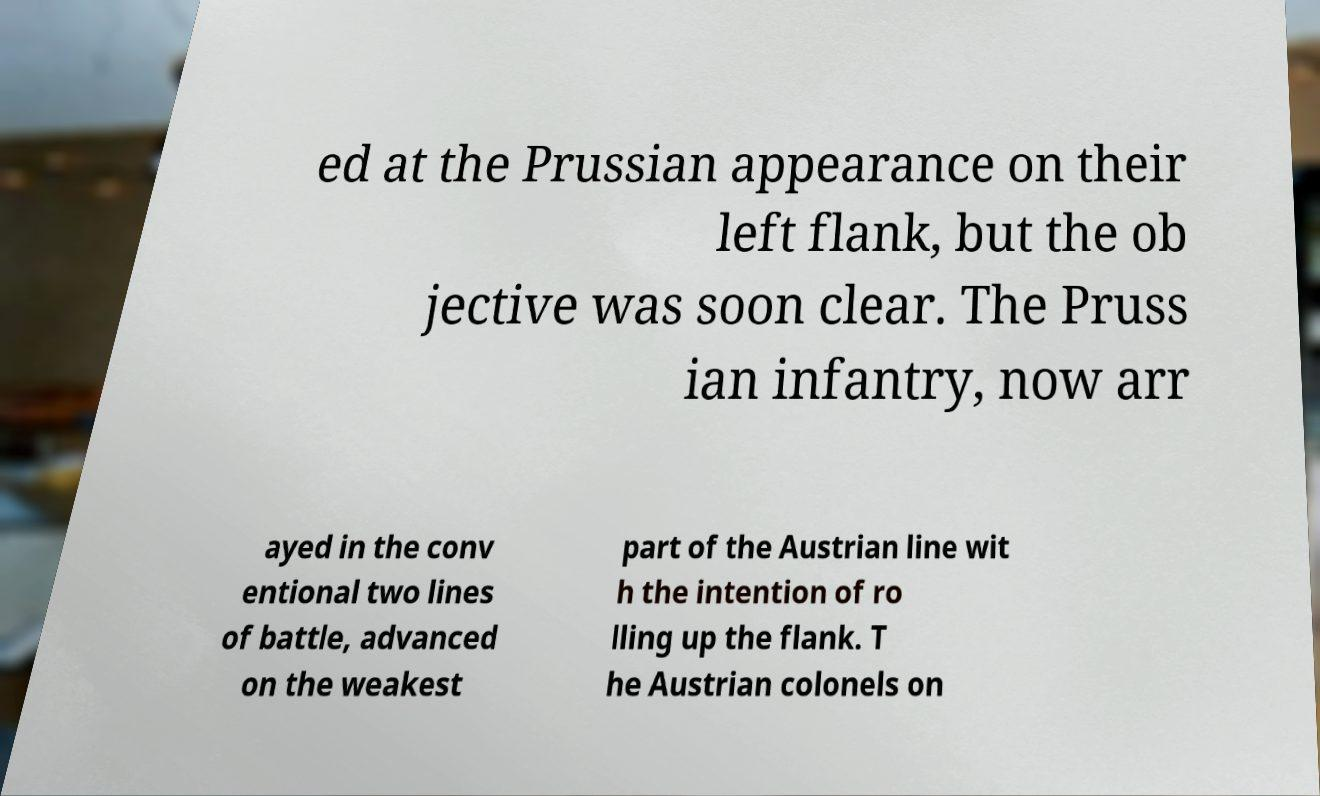Please identify and transcribe the text found in this image. ed at the Prussian appearance on their left flank, but the ob jective was soon clear. The Pruss ian infantry, now arr ayed in the conv entional two lines of battle, advanced on the weakest part of the Austrian line wit h the intention of ro lling up the flank. T he Austrian colonels on 